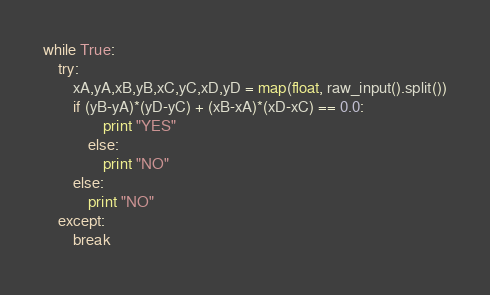Convert code to text. <code><loc_0><loc_0><loc_500><loc_500><_Python_>while True:
    try:
        xA,yA,xB,yB,xC,yC,xD,yD = map(float, raw_input().split())
        if (yB-yA)*(yD-yC) + (xB-xA)*(xD-xC) == 0.0:
                print "YES"
            else:
                print "NO"
        else:
            print "NO"
    except:
        break</code> 